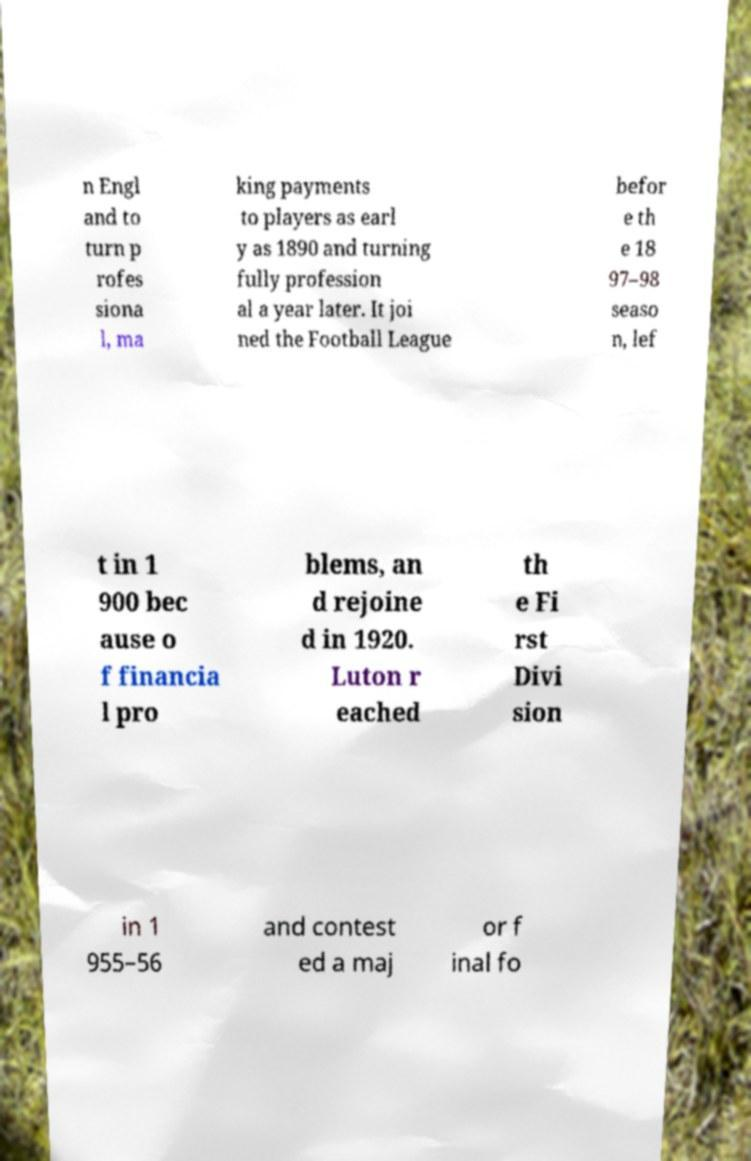Please identify and transcribe the text found in this image. n Engl and to turn p rofes siona l, ma king payments to players as earl y as 1890 and turning fully profession al a year later. It joi ned the Football League befor e th e 18 97–98 seaso n, lef t in 1 900 bec ause o f financia l pro blems, an d rejoine d in 1920. Luton r eached th e Fi rst Divi sion in 1 955–56 and contest ed a maj or f inal fo 